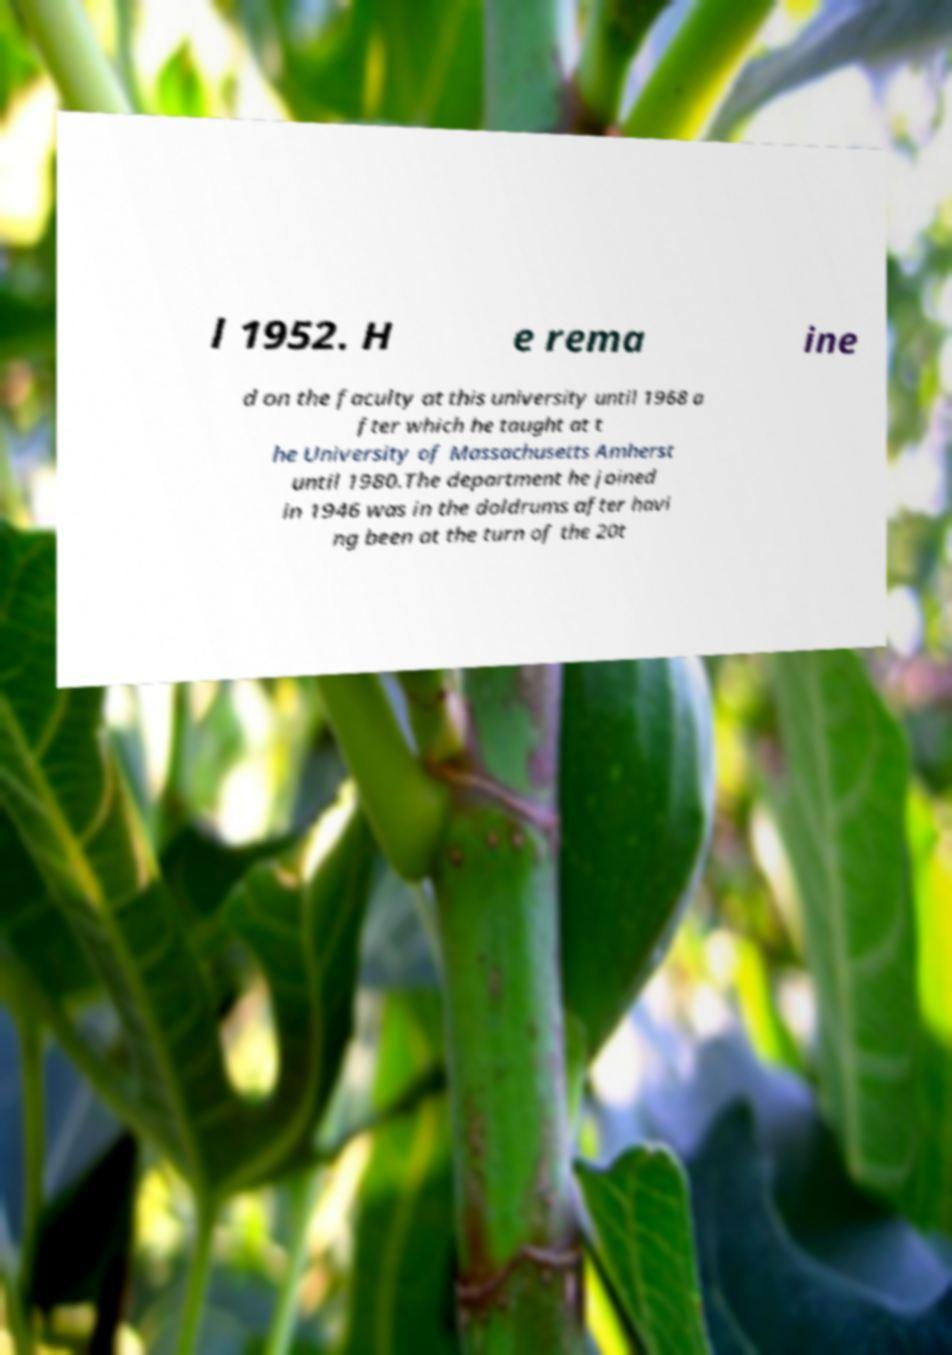Can you read and provide the text displayed in the image?This photo seems to have some interesting text. Can you extract and type it out for me? l 1952. H e rema ine d on the faculty at this university until 1968 a fter which he taught at t he University of Massachusetts Amherst until 1980.The department he joined in 1946 was in the doldrums after havi ng been at the turn of the 20t 